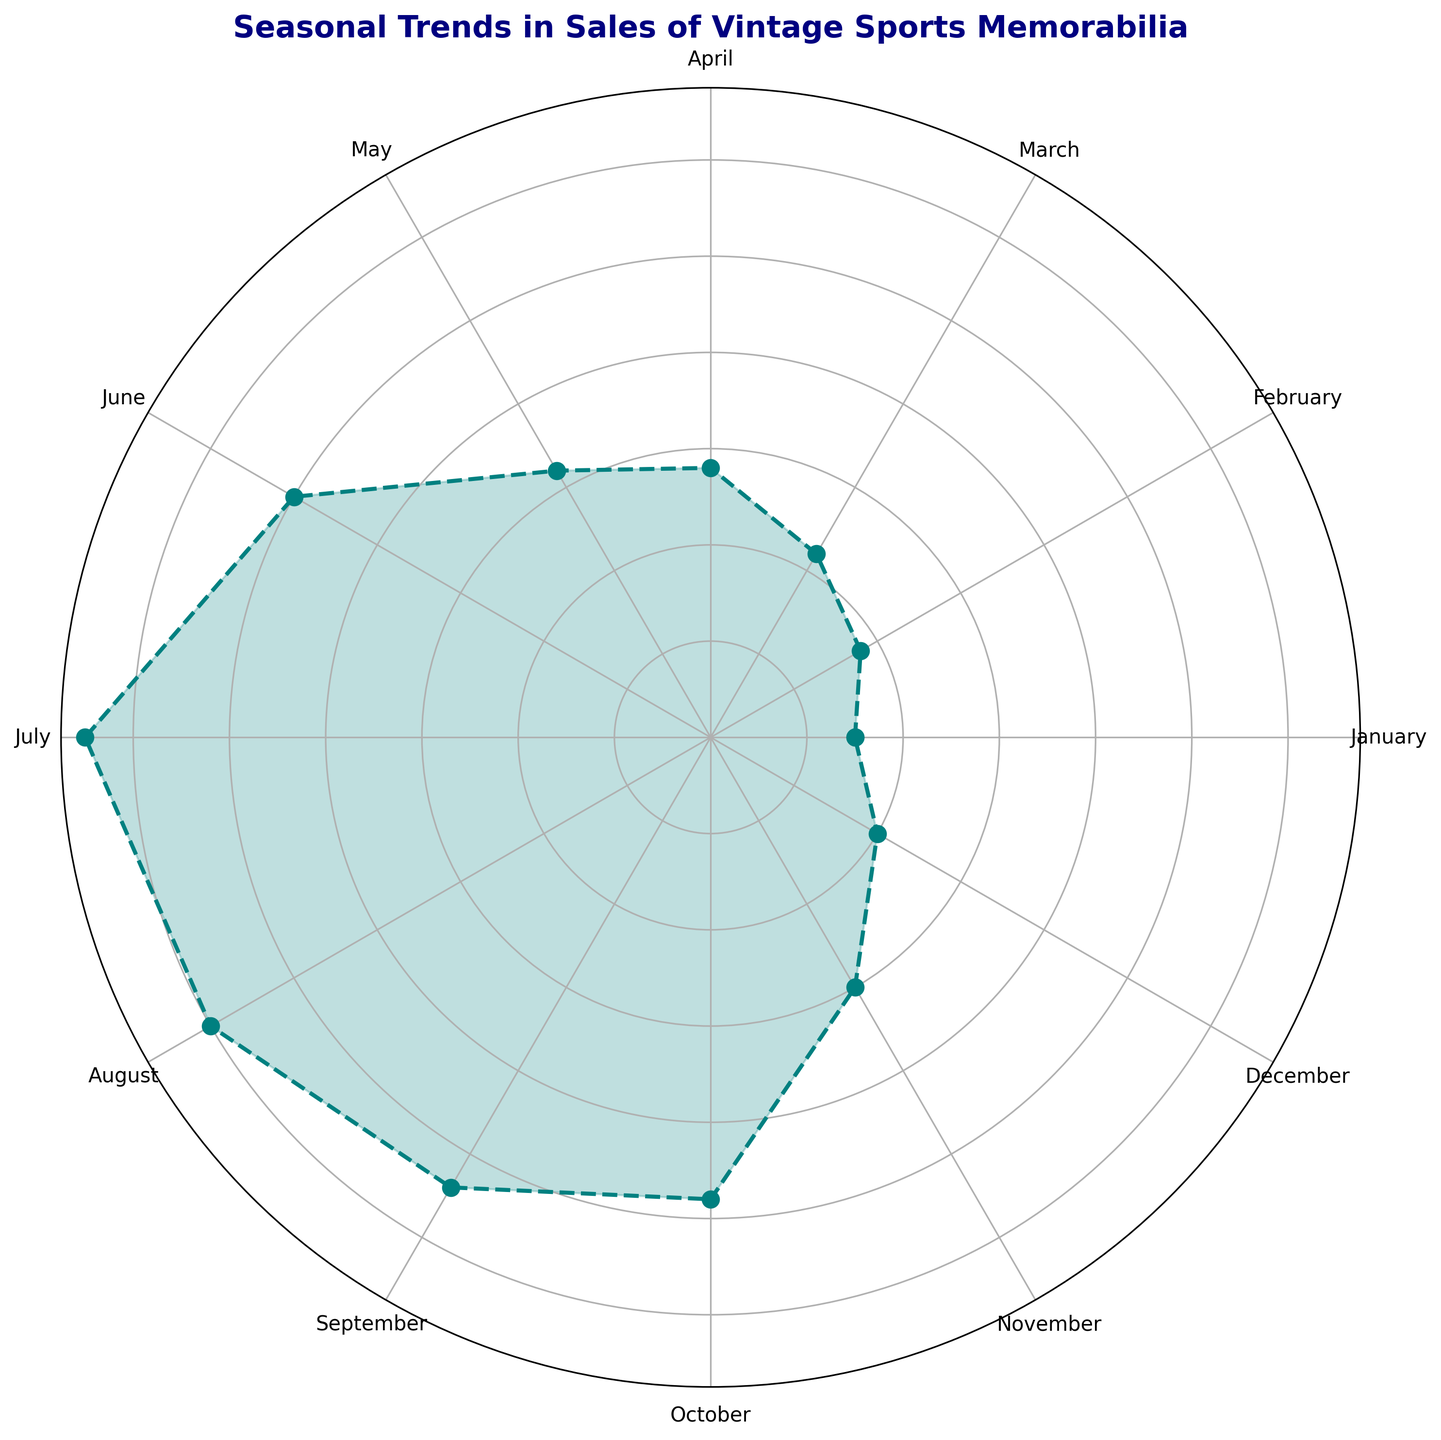what is the month with the highest sales? By observing the chart, we need to find the month with the highest point on the figure. June is visually located at the highest sales point compared to other months.
Answer: June Which two months have the closest sales figures? By examining the plot, we detect that November and December have very close points on the figure, indicating similar sales figures.
Answer: November and December What is the average sales from March to May? Locate the points corresponding to March, April, and May, sum their sales (220 + 280 + 320) to get 820, and then divide by 3 to find the average: 820/3 ≈ 273.33.
Answer: 273.33 By how much do sales increase from February to June? Identify the sales in February and June, which are 180 and 500, respectively. Subtract February's sales from June's sales: 500 - 180 = 320.
Answer: 320 What is the month with the lowest sales? Locate the month with the lowest point on the figure. It is January with the lowest sales figure of 150.
Answer: January How do the sales in July compare to October? Check the points for July and October, where July has 650 sales and October has 480 sales. July's sales are greater than October's.
Answer: July's sales are greater What is the total sales for the last quarter? Identify the sales for October, November, and December (480 + 300 + 200), sum them up to get the total: 480 + 300 + 200 = 980.
Answer: 980 Which month sees a significant rise in sales compared to its previous month? By examining the changes in sales month-over-month, we notice a significant rise from May (320) to June (500).
Answer: June If the months were grouped by seasons (Winter: Dec-Feb, Spring: Mar-May, Summer: Jun-Aug, Fall: Sep-Nov), which season has the highest total sales? Calculate the total sales for each season: 
Winter (150+180+200)=530, Spring (220+280+320)=820, Summer (500+650+600)=1750, Fall (540+480+300)=1320. Summer has the highest total sales.
Answer: Summer 